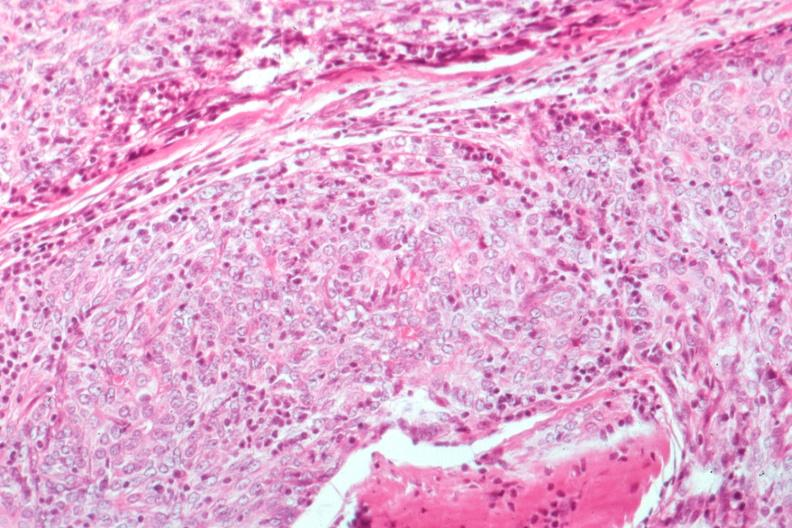what is present?
Answer the question using a single word or phrase. Thymoma 